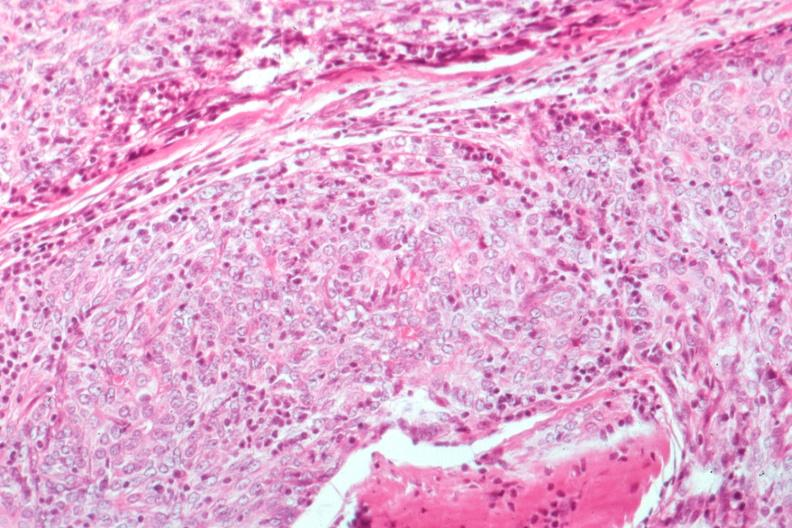what is present?
Answer the question using a single word or phrase. Thymoma 